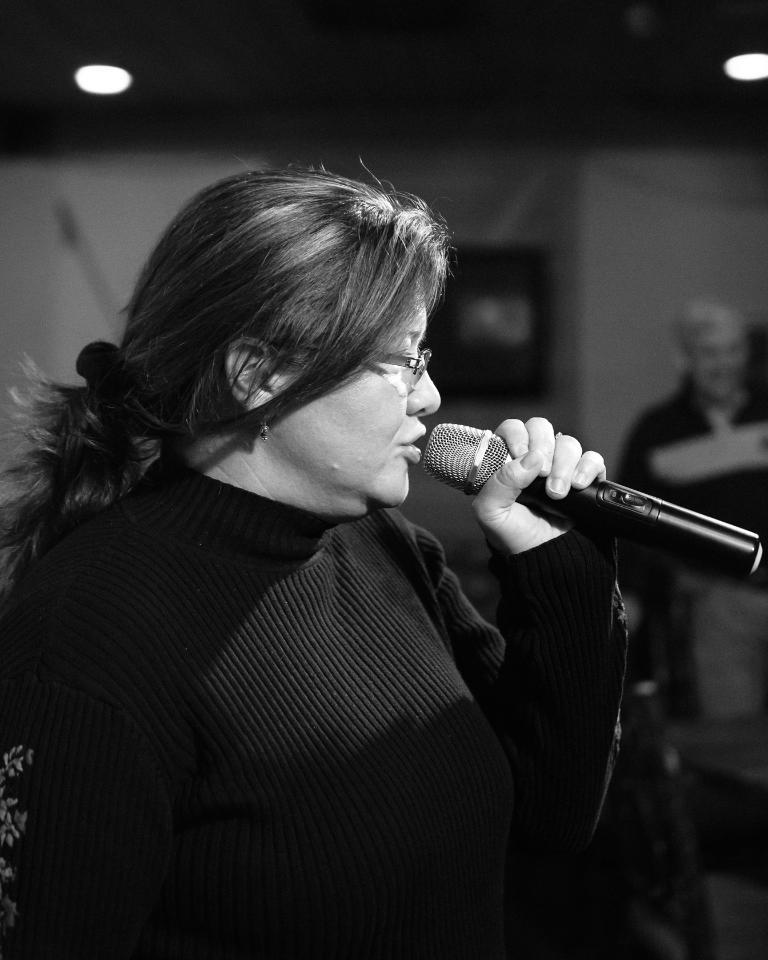What is the woman in the image doing? The woman is singing in the image. What is the woman holding while singing? The woman is holding a microphone. Can you describe the woman's appearance in the image? The woman is wearing spectacles and a dress. What can be seen on the left side of the image? There is a light on the left side of the image. Who else is present in the image? There is a man on the right side of the image. What type of egg is being used as a prop in the image? There is no egg present in the image; it features a woman singing with a microphone and a man on the right side. 